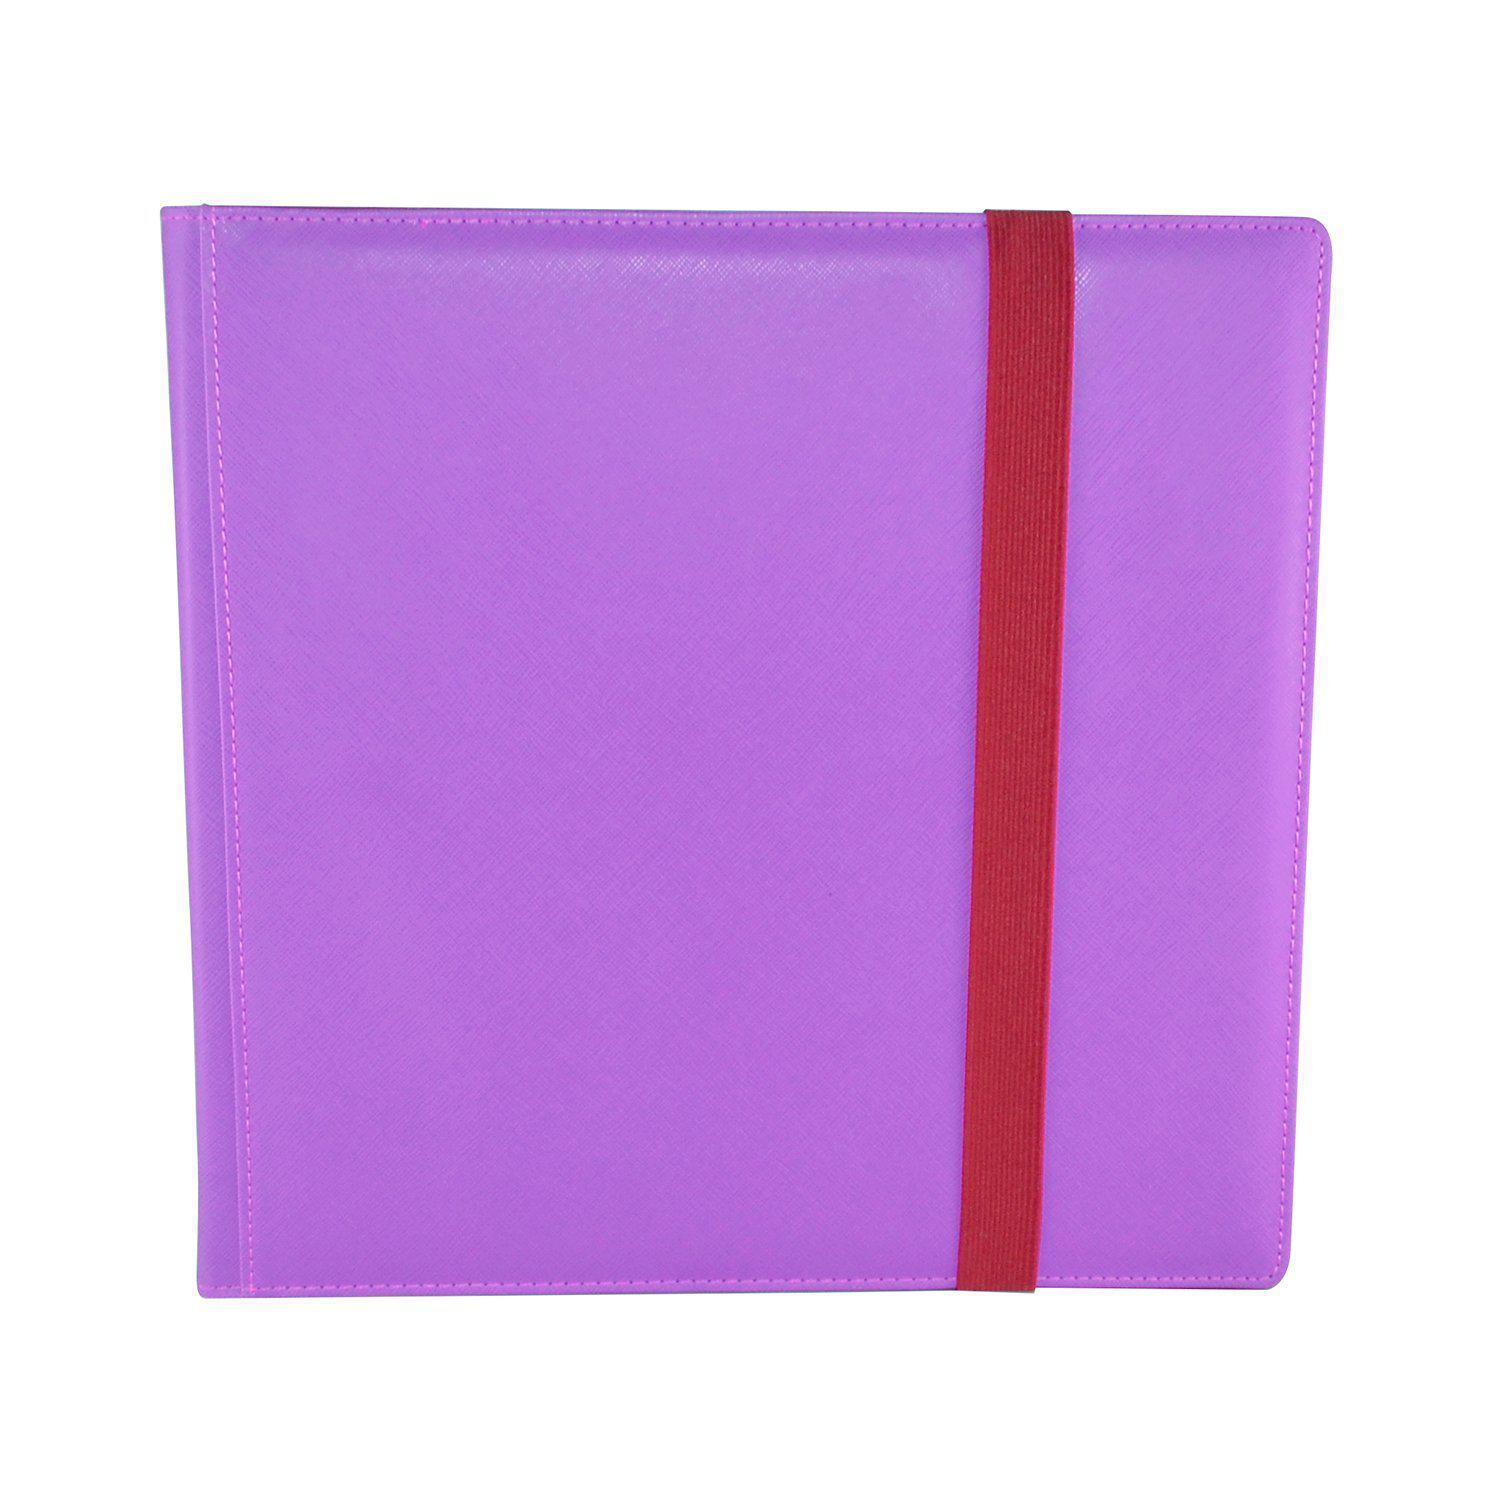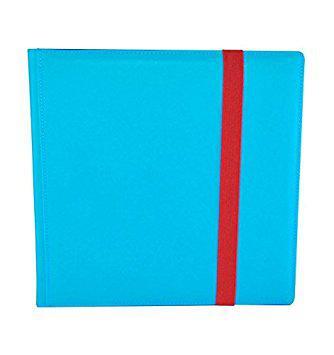The first image is the image on the left, the second image is the image on the right. Assess this claim about the two images: "In one image, a black album with red trim is show both open and closed.". Correct or not? Answer yes or no. No. 